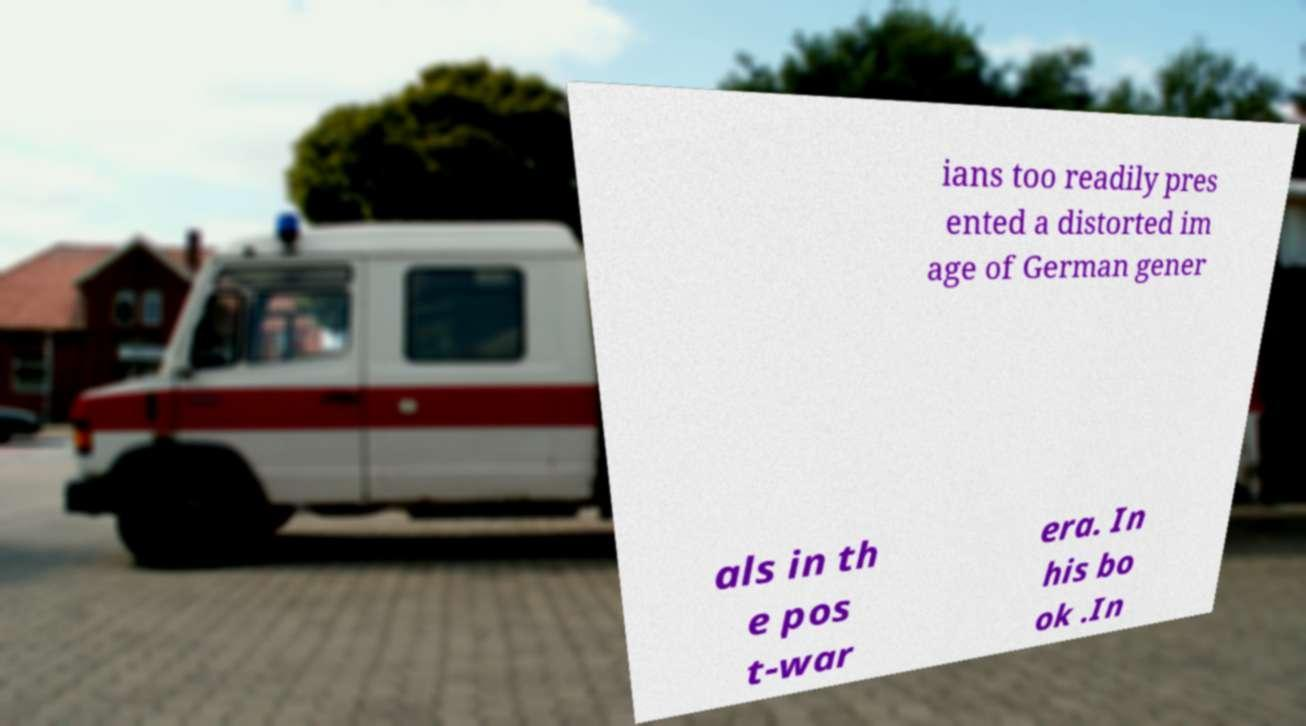There's text embedded in this image that I need extracted. Can you transcribe it verbatim? ians too readily pres ented a distorted im age of German gener als in th e pos t-war era. In his bo ok .In 